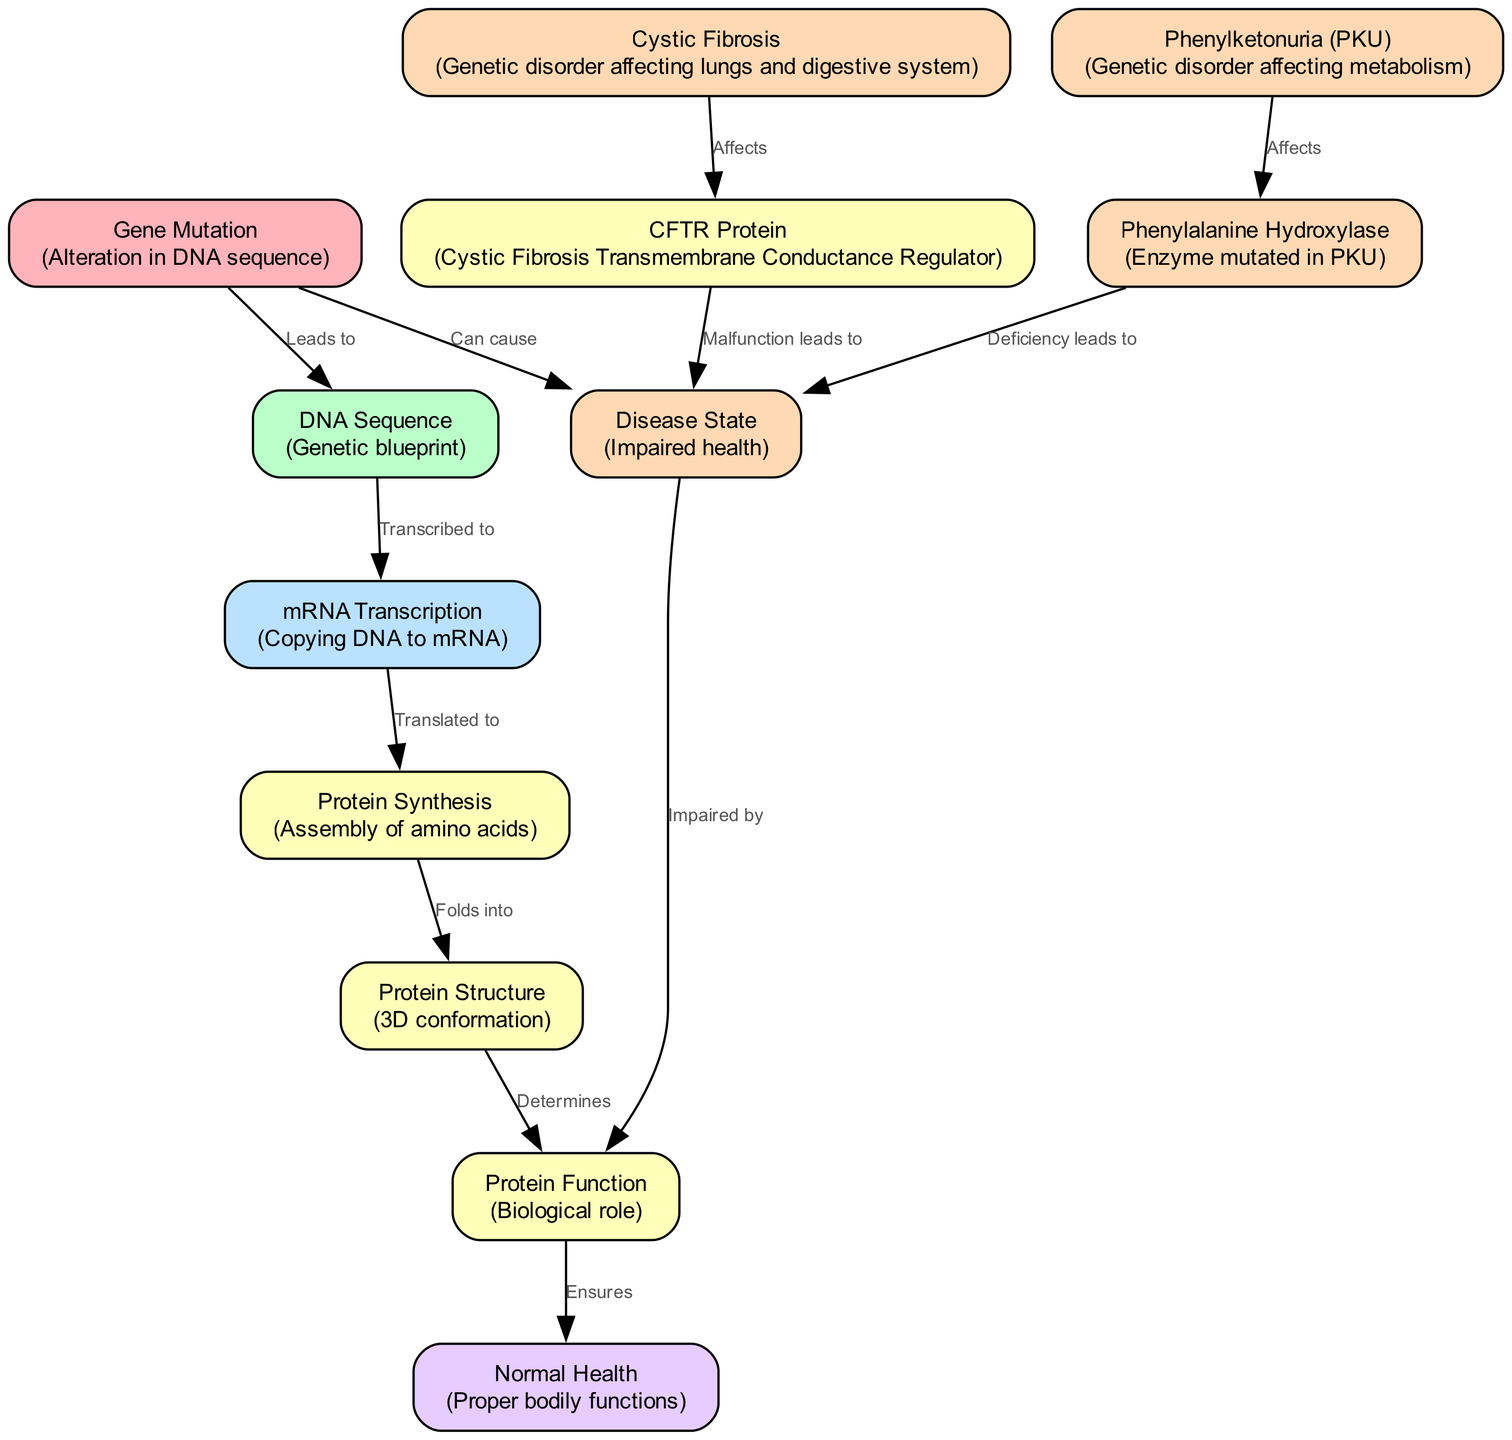What is the first node in the diagram? The first node listed in the data represents "Gene Mutation," which indicates an alteration in the DNA sequence and initiates the process illustrated in the diagram.
Answer: Gene Mutation How many nodes are present in the diagram? By counting the entries in the "nodes" section of the data, there are a total of 12 distinct nodes representing various components related to genetic mutations and their effects.
Answer: 12 What does the CFTR protein affect? According to the diagram, the CFTR protein is affected by cystic fibrosis, which specifically impacts this protein's function relating to health and disease.
Answer: Cystic Fibrosis What is the relationship between protein structure and protein function? The diagram shows that protein structure determines protein function, indicating that the three-dimensional conformation of a protein directly influences its biological role.
Answer: Determines Which mutation leads to a deficiency in phenylalanine hydroxylase? The term "Phenylketonuria" in the diagram indicates that this genetic disorder affects the enzyme phenylalanine hydroxylase, leading to its deficiency.
Answer: Phenylketonuria How does a gene mutation influence normal health? The flow in the diagram indicates that a gene mutation, by affecting various processes including the protein function, can lead to consequences that impair normal health. The connection highlights a cause-and-effect relationship.
Answer: Can cause What happens when the CFTR protein malfunctions? The diagram specifies that a malfunction in the CFTR protein leads to a diseased state, which implies a significant disruption of health attributed to the genetic condition related to cystic fibrosis.
Answer: Malfunction leads to What type of disorder is phenylketonuria? The term "genetic disorder" is used in the description of phenylketonuria in the diagram, specifying the classification of this disease that impacts metabolism.
Answer: Genetic disorder Which process follows mRNA transcription? In the diagram, the next step after mRNA transcription is protein synthesis, illustrating the flow of genetic information from DNA to eventual protein formation.
Answer: Protein Synthesis 